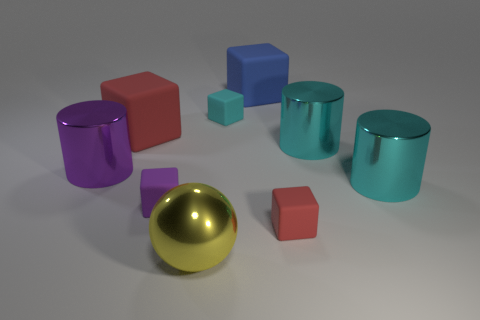Are there any other things of the same color as the big sphere?
Keep it short and to the point. No. How big is the shiny thing in front of the cyan thing that is in front of the big purple metallic cylinder?
Your answer should be very brief. Large. The cube that is both right of the cyan block and in front of the large blue rubber cube is what color?
Offer a terse response. Red. How many other things are the same size as the cyan matte thing?
Make the answer very short. 2. There is a purple cube; is it the same size as the red rubber object that is in front of the large purple shiny object?
Your answer should be compact. Yes. There is another matte cube that is the same size as the blue matte block; what is its color?
Provide a succinct answer. Red. How big is the ball?
Ensure brevity in your answer.  Large. Is the material of the red cube that is left of the blue matte thing the same as the tiny cyan object?
Your answer should be very brief. Yes. Is the big blue thing the same shape as the big red rubber object?
Offer a very short reply. Yes. What is the shape of the cyan thing that is behind the red rubber block behind the cylinder that is left of the small red cube?
Make the answer very short. Cube. 